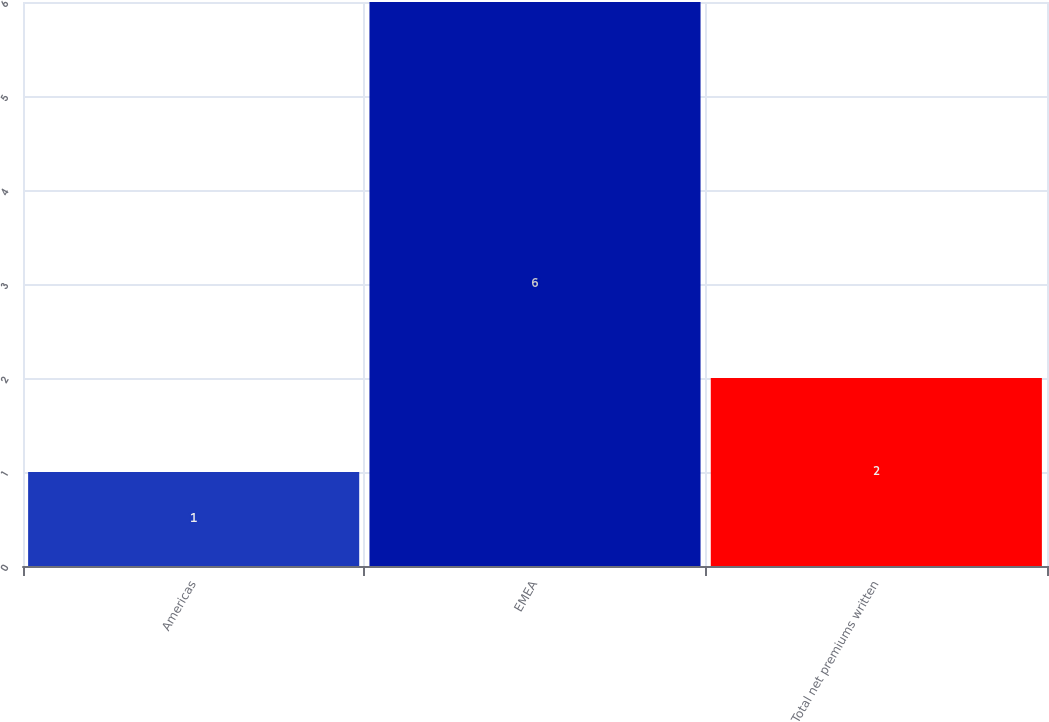<chart> <loc_0><loc_0><loc_500><loc_500><bar_chart><fcel>Americas<fcel>EMEA<fcel>Total net premiums written<nl><fcel>1<fcel>6<fcel>2<nl></chart> 